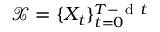<formula> <loc_0><loc_0><loc_500><loc_500>\mathcal { X } = \{ X _ { t } \} _ { t = 0 } ^ { T - d t }</formula> 